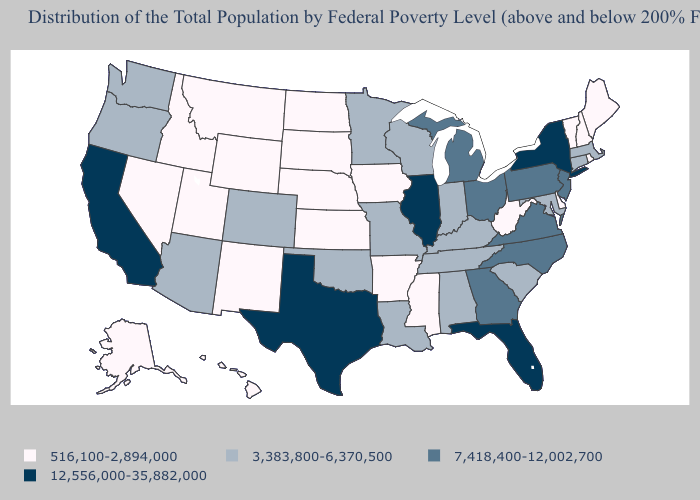What is the value of Wisconsin?
Quick response, please. 3,383,800-6,370,500. Does Maine have the lowest value in the Northeast?
Keep it brief. Yes. What is the value of Utah?
Write a very short answer. 516,100-2,894,000. What is the highest value in the USA?
Write a very short answer. 12,556,000-35,882,000. What is the value of Washington?
Short answer required. 3,383,800-6,370,500. Is the legend a continuous bar?
Short answer required. No. Name the states that have a value in the range 3,383,800-6,370,500?
Keep it brief. Alabama, Arizona, Colorado, Connecticut, Indiana, Kentucky, Louisiana, Maryland, Massachusetts, Minnesota, Missouri, Oklahoma, Oregon, South Carolina, Tennessee, Washington, Wisconsin. Is the legend a continuous bar?
Short answer required. No. Among the states that border Washington , does Idaho have the lowest value?
Answer briefly. Yes. Does the map have missing data?
Be succinct. No. Name the states that have a value in the range 516,100-2,894,000?
Write a very short answer. Alaska, Arkansas, Delaware, Hawaii, Idaho, Iowa, Kansas, Maine, Mississippi, Montana, Nebraska, Nevada, New Hampshire, New Mexico, North Dakota, Rhode Island, South Dakota, Utah, Vermont, West Virginia, Wyoming. Name the states that have a value in the range 12,556,000-35,882,000?
Be succinct. California, Florida, Illinois, New York, Texas. Name the states that have a value in the range 12,556,000-35,882,000?
Short answer required. California, Florida, Illinois, New York, Texas. Which states have the lowest value in the USA?
Write a very short answer. Alaska, Arkansas, Delaware, Hawaii, Idaho, Iowa, Kansas, Maine, Mississippi, Montana, Nebraska, Nevada, New Hampshire, New Mexico, North Dakota, Rhode Island, South Dakota, Utah, Vermont, West Virginia, Wyoming. 